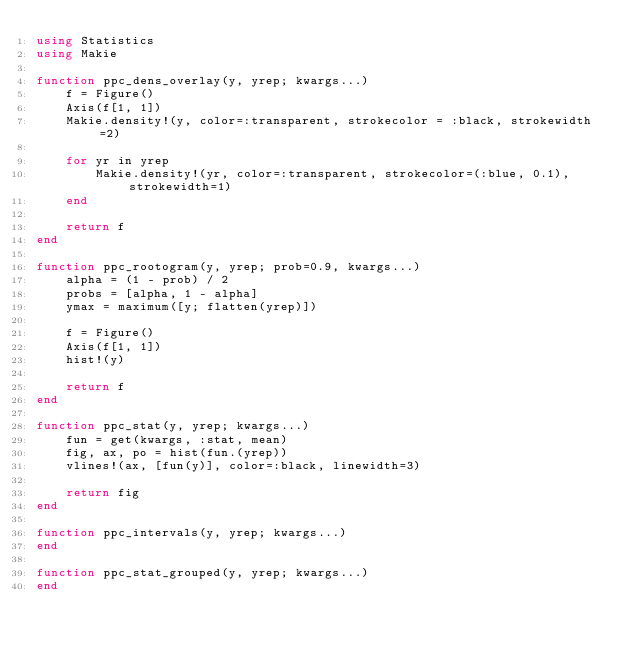<code> <loc_0><loc_0><loc_500><loc_500><_Julia_>using Statistics
using Makie

function ppc_dens_overlay(y, yrep; kwargs...)
    f = Figure()
    Axis(f[1, 1])
    Makie.density!(y, color=:transparent, strokecolor = :black, strokewidth=2)

    for yr in yrep
        Makie.density!(yr, color=:transparent, strokecolor=(:blue, 0.1), strokewidth=1)
    end

    return f
end

function ppc_rootogram(y, yrep; prob=0.9, kwargs...)
    alpha = (1 - prob) / 2
    probs = [alpha, 1 - alpha]
    ymax = maximum([y; flatten(yrep)])

    f = Figure()
    Axis(f[1, 1])
    hist!(y)

    return f
end

function ppc_stat(y, yrep; kwargs...)
    fun = get(kwargs, :stat, mean)
    fig, ax, po = hist(fun.(yrep))
    vlines!(ax, [fun(y)], color=:black, linewidth=3)

    return fig
end

function ppc_intervals(y, yrep; kwargs...)
end

function ppc_stat_grouped(y, yrep; kwargs...)
end
</code> 